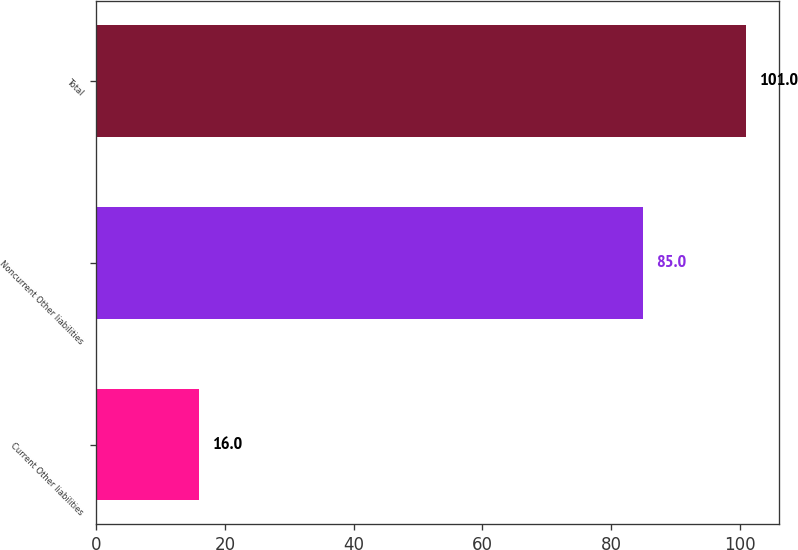Convert chart to OTSL. <chart><loc_0><loc_0><loc_500><loc_500><bar_chart><fcel>Current Other liabilities<fcel>Noncurrent Other liabilities<fcel>Total<nl><fcel>16<fcel>85<fcel>101<nl></chart> 